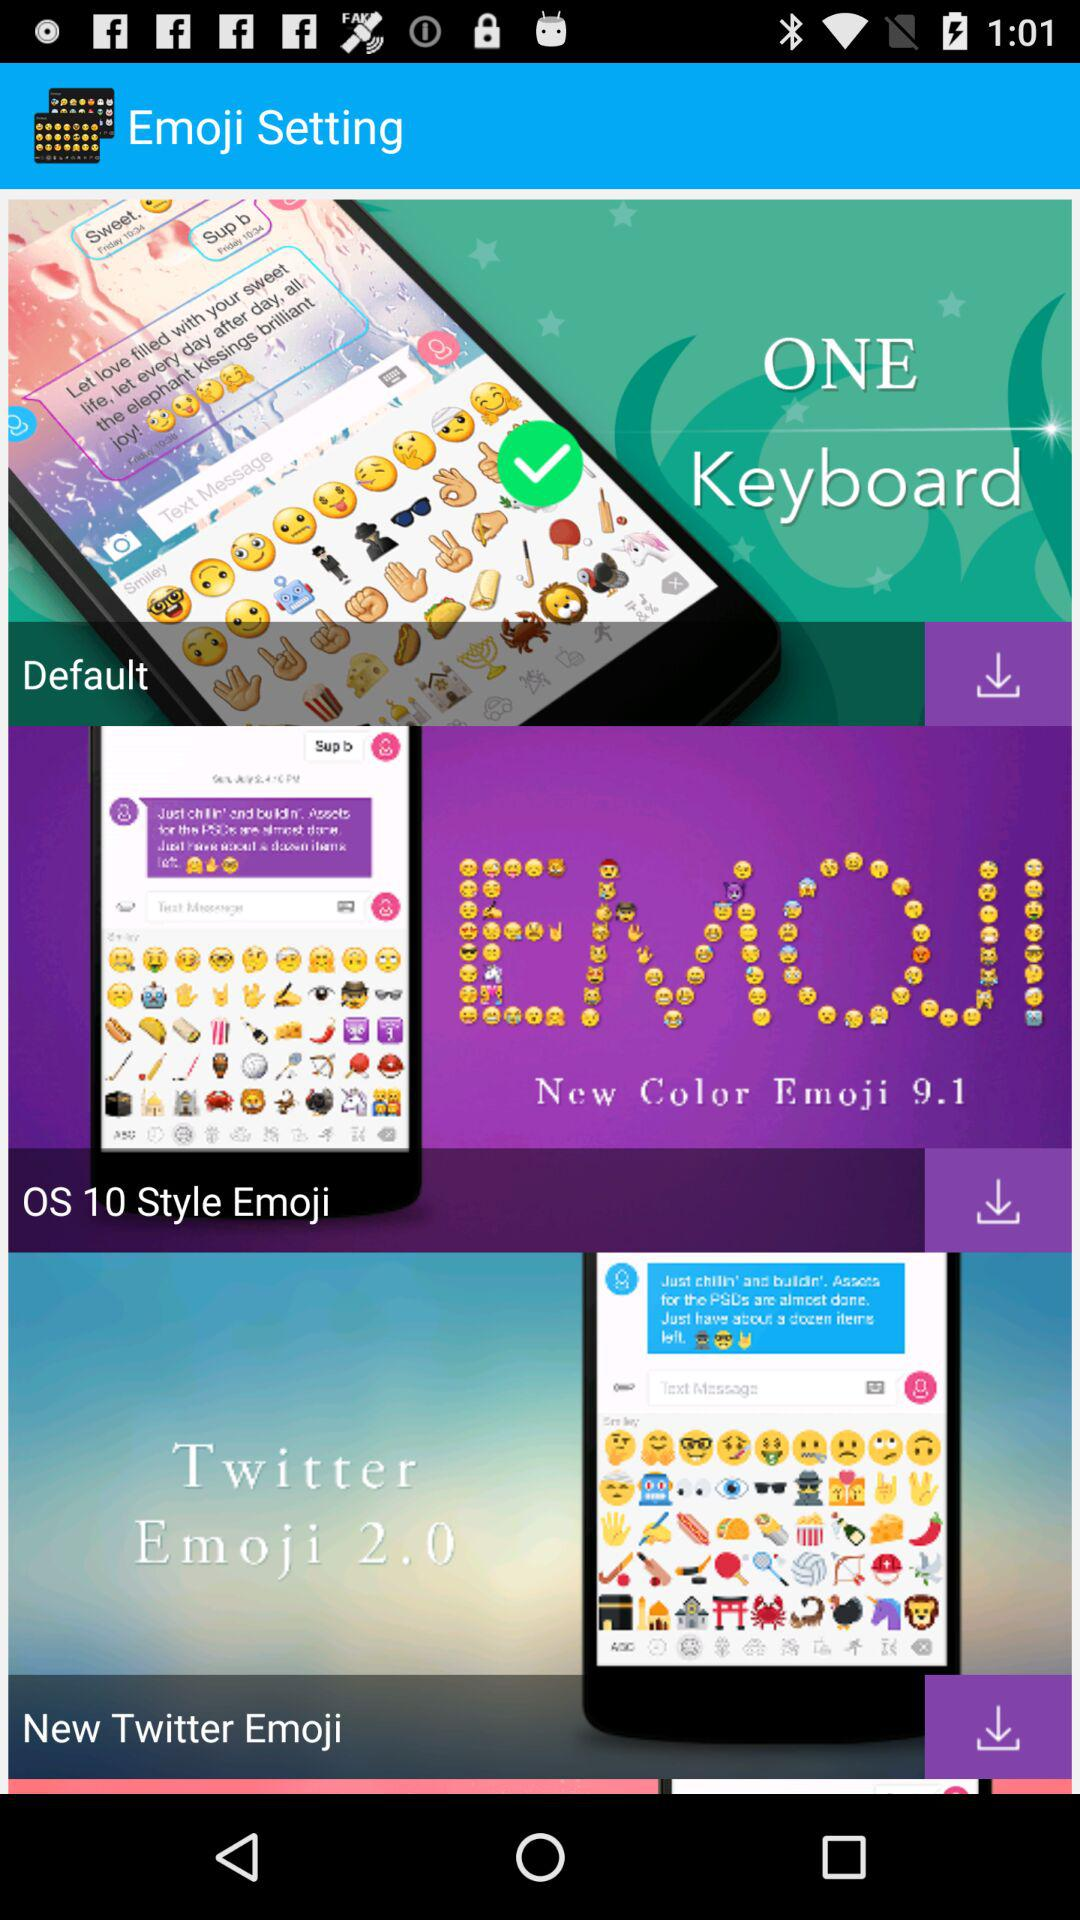Which "Twitter Emoji" version is used? The used version is 2.0. 